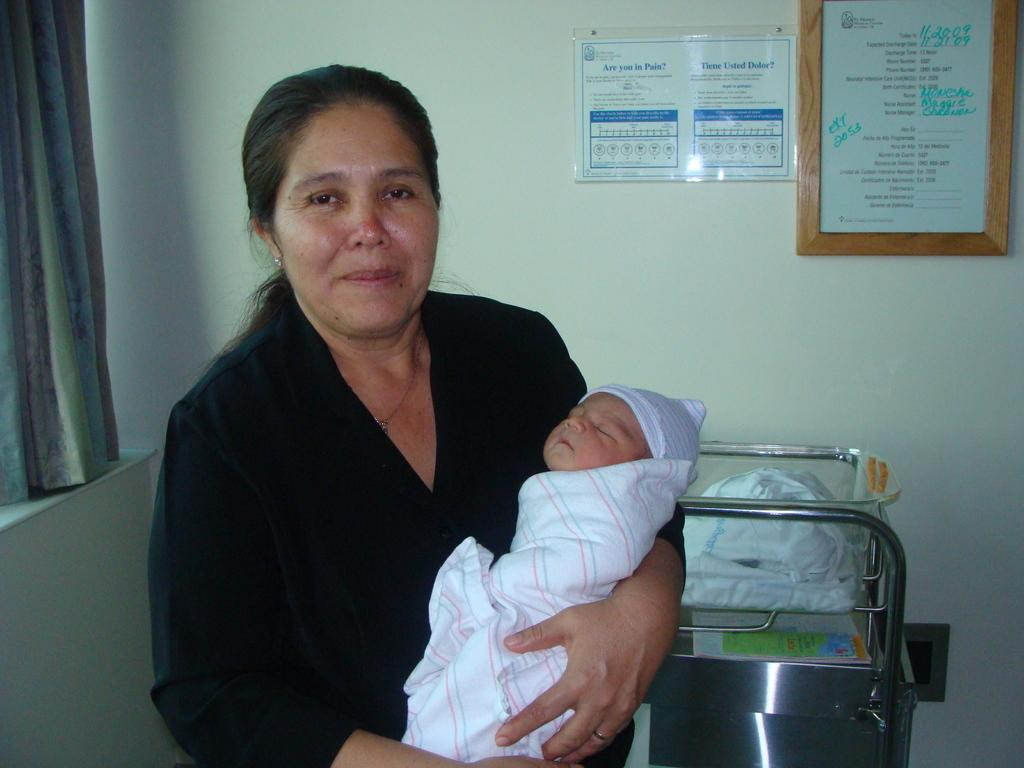<image>
Summarize the visual content of the image. Woman with a newborn in front of a poster asking if the reader is in pain. 